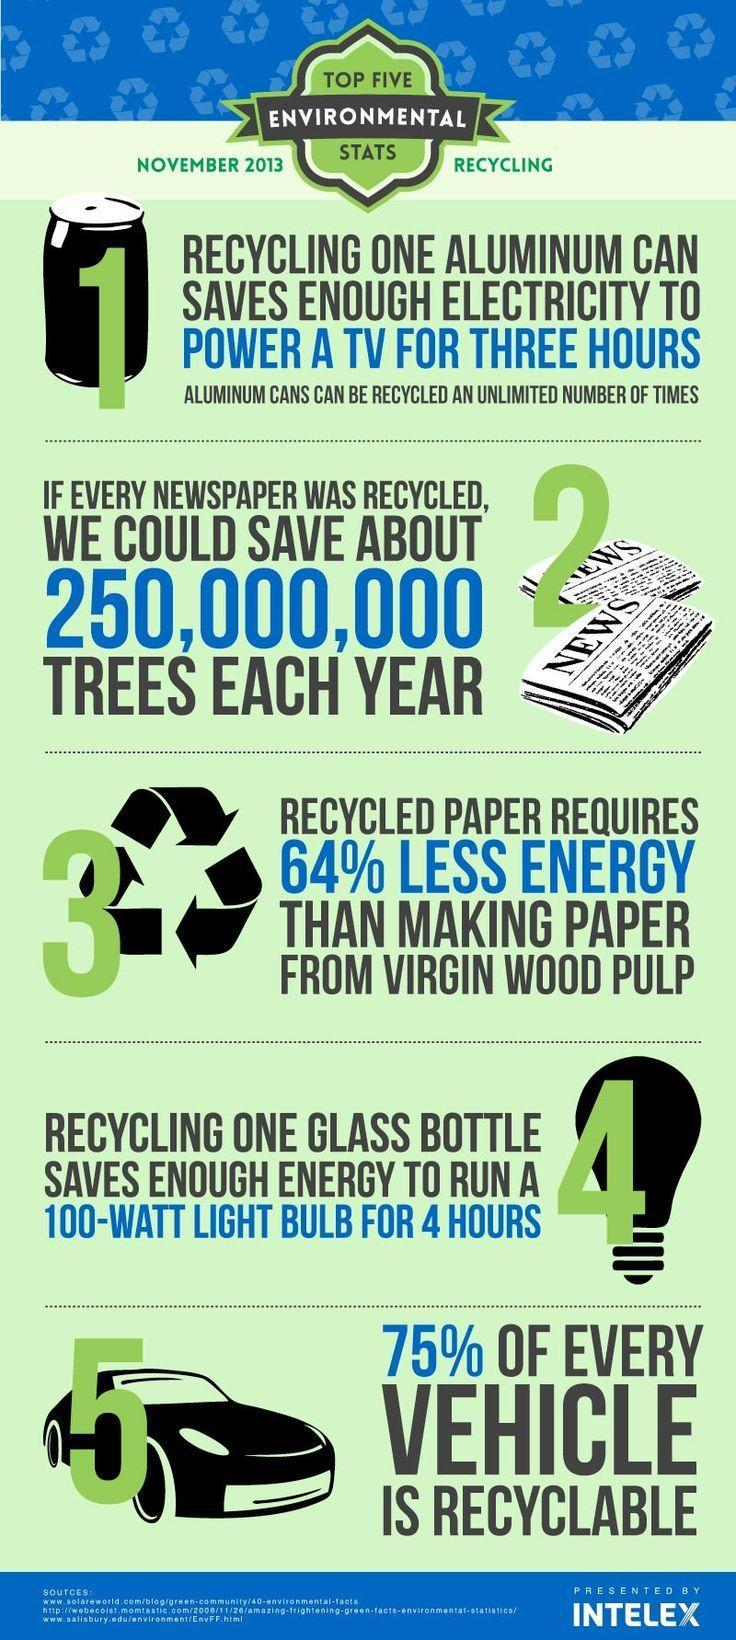Making which type of paper requires more energy ?
Answer the question with a short phrase. paper from virgin wood pulp 